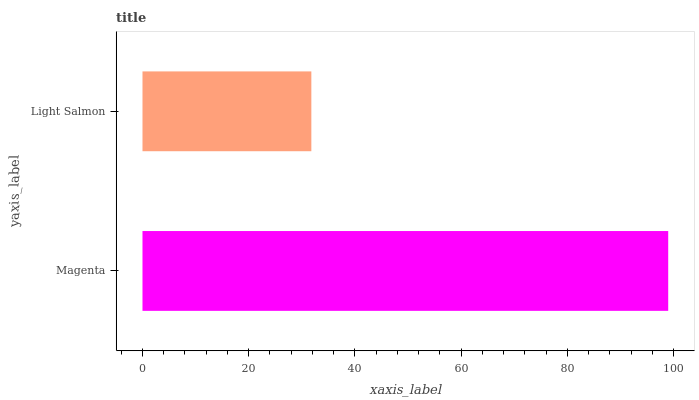Is Light Salmon the minimum?
Answer yes or no. Yes. Is Magenta the maximum?
Answer yes or no. Yes. Is Light Salmon the maximum?
Answer yes or no. No. Is Magenta greater than Light Salmon?
Answer yes or no. Yes. Is Light Salmon less than Magenta?
Answer yes or no. Yes. Is Light Salmon greater than Magenta?
Answer yes or no. No. Is Magenta less than Light Salmon?
Answer yes or no. No. Is Magenta the high median?
Answer yes or no. Yes. Is Light Salmon the low median?
Answer yes or no. Yes. Is Light Salmon the high median?
Answer yes or no. No. Is Magenta the low median?
Answer yes or no. No. 